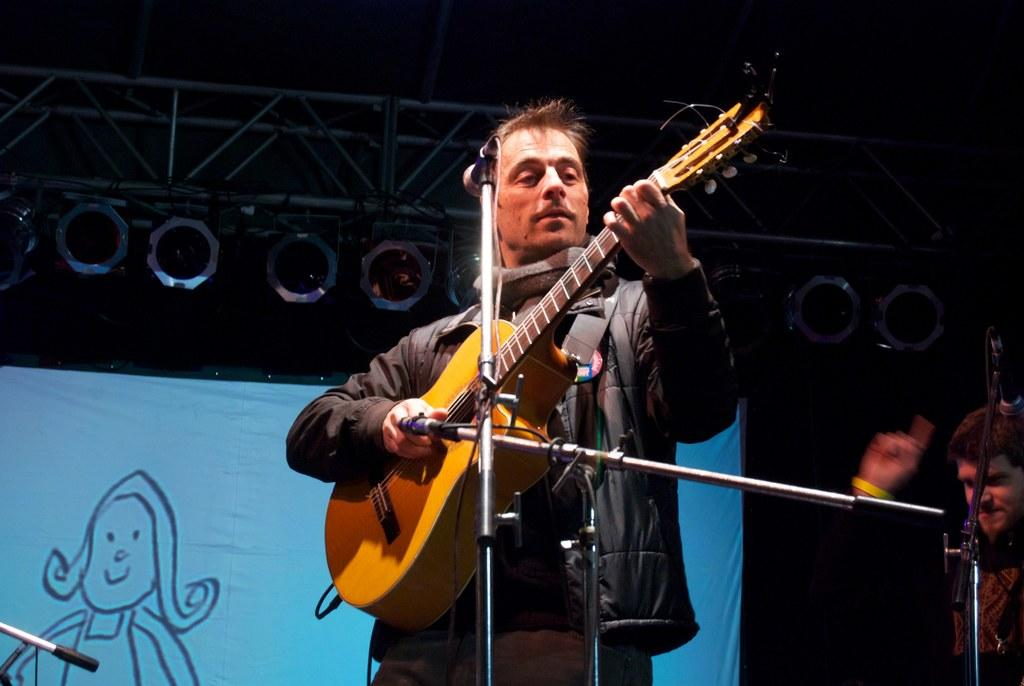What can be seen in the image that provides illumination? There are lights in the image. How many people are present in the image? There are two people standing in the image. What is one of the people holding? One of the people is holding a guitar. What object is in front of the person holding the guitar? There is a microphone in front of the person holding the guitar. What type of nut is being cracked by the person holding the guitar in the image? There is no nut or any activity involving a nut present in the image. Can you describe the family members in the image? The provided facts do not mention any family members, so we cannot describe them. 